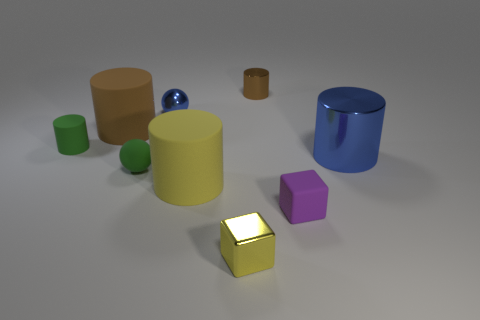Subtract 2 cylinders. How many cylinders are left? 3 Subtract all yellow cylinders. How many cylinders are left? 4 Subtract all small matte cylinders. How many cylinders are left? 4 Subtract all purple cylinders. Subtract all red blocks. How many cylinders are left? 5 Add 1 tiny things. How many objects exist? 10 Subtract all spheres. How many objects are left? 7 Subtract 0 red spheres. How many objects are left? 9 Subtract all large purple objects. Subtract all small green cylinders. How many objects are left? 8 Add 2 purple matte things. How many purple matte things are left? 3 Add 8 big red rubber cubes. How many big red rubber cubes exist? 8 